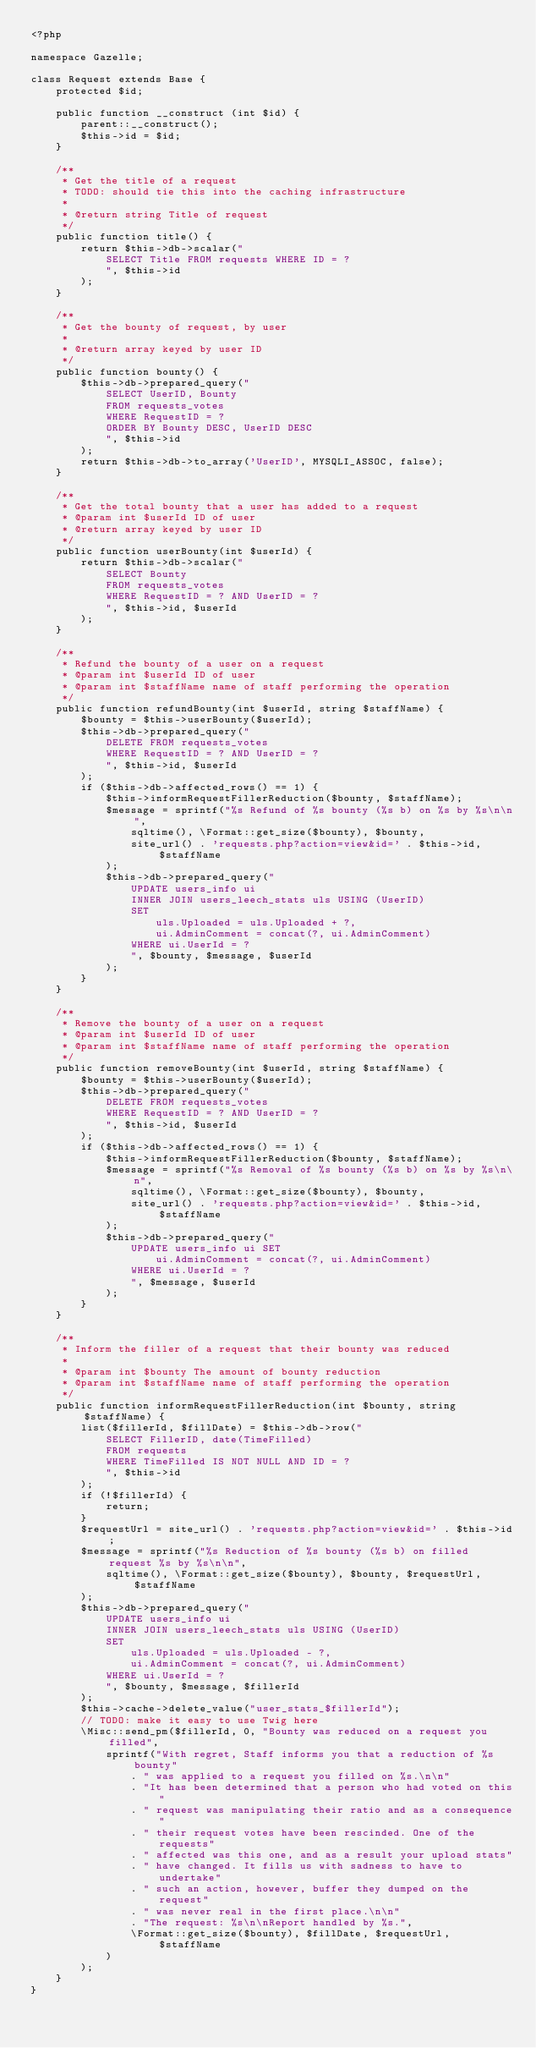<code> <loc_0><loc_0><loc_500><loc_500><_PHP_><?php

namespace Gazelle;

class Request extends Base {
    protected $id;

    public function __construct (int $id) {
        parent::__construct();
        $this->id = $id;
    }

    /**
     * Get the title of a request
     * TODO: should tie this into the caching infrastructure
     *
     * @return string Title of request
     */
    public function title() {
        return $this->db->scalar("
            SELECT Title FROM requests WHERE ID = ?
            ", $this->id
        );
    }

    /**
     * Get the bounty of request, by user
     *
     * @return array keyed by user ID
     */
    public function bounty() {
        $this->db->prepared_query("
            SELECT UserID, Bounty
            FROM requests_votes
            WHERE RequestID = ?
            ORDER BY Bounty DESC, UserID DESC
            ", $this->id
        );
        return $this->db->to_array('UserID', MYSQLI_ASSOC, false);
    }

    /**
     * Get the total bounty that a user has added to a request
     * @param int $userId ID of user
     * @return array keyed by user ID
     */
    public function userBounty(int $userId) {
        return $this->db->scalar("
            SELECT Bounty
            FROM requests_votes
            WHERE RequestID = ? AND UserID = ?
            ", $this->id, $userId
        );
    }

    /**
     * Refund the bounty of a user on a request
     * @param int $userId ID of user
     * @param int $staffName name of staff performing the operation
     */
    public function refundBounty(int $userId, string $staffName) {
        $bounty = $this->userBounty($userId);
        $this->db->prepared_query("
            DELETE FROM requests_votes
            WHERE RequestID = ? AND UserID = ?
            ", $this->id, $userId
        );
        if ($this->db->affected_rows() == 1) {
            $this->informRequestFillerReduction($bounty, $staffName);
            $message = sprintf("%s Refund of %s bounty (%s b) on %s by %s\n\n",
                sqltime(), \Format::get_size($bounty), $bounty,
                site_url() . 'requests.php?action=view&id=' . $this->id, $staffName
            );
            $this->db->prepared_query("
                UPDATE users_info ui
                INNER JOIN users_leech_stats uls USING (UserID)
                SET
                    uls.Uploaded = uls.Uploaded + ?,
                    ui.AdminComment = concat(?, ui.AdminComment)
                WHERE ui.UserId = ?
                ", $bounty, $message, $userId
            );
        }
    }

    /**
     * Remove the bounty of a user on a request
     * @param int $userId ID of user
     * @param int $staffName name of staff performing the operation
     */
    public function removeBounty(int $userId, string $staffName) {
        $bounty = $this->userBounty($userId);
        $this->db->prepared_query("
            DELETE FROM requests_votes
            WHERE RequestID = ? AND UserID = ?
            ", $this->id, $userId
        );
        if ($this->db->affected_rows() == 1) {
            $this->informRequestFillerReduction($bounty, $staffName);
            $message = sprintf("%s Removal of %s bounty (%s b) on %s by %s\n\n",
                sqltime(), \Format::get_size($bounty), $bounty,
                site_url() . 'requests.php?action=view&id=' . $this->id, $staffName
            );
            $this->db->prepared_query("
                UPDATE users_info ui SET
                    ui.AdminComment = concat(?, ui.AdminComment)
                WHERE ui.UserId = ?
                ", $message, $userId
            );
        }
    }

    /**
     * Inform the filler of a request that their bounty was reduced
     *
     * @param int $bounty The amount of bounty reduction
     * @param int $staffName name of staff performing the operation
     */
    public function informRequestFillerReduction(int $bounty, string $staffName) {
        list($fillerId, $fillDate) = $this->db->row("
            SELECT FillerID, date(TimeFilled)
            FROM requests
            WHERE TimeFilled IS NOT NULL AND ID = ?
            ", $this->id
        );
        if (!$fillerId) {
            return;
        }
        $requestUrl = site_url() . 'requests.php?action=view&id=' . $this->id;
        $message = sprintf("%s Reduction of %s bounty (%s b) on filled request %s by %s\n\n",
            sqltime(), \Format::get_size($bounty), $bounty, $requestUrl, $staffName
        );
        $this->db->prepared_query("
            UPDATE users_info ui
            INNER JOIN users_leech_stats uls USING (UserID)
            SET
                uls.Uploaded = uls.Uploaded - ?,
                ui.AdminComment = concat(?, ui.AdminComment)
            WHERE ui.UserId = ?
            ", $bounty, $message, $fillerId
        );
        $this->cache->delete_value("user_stats_$fillerId");
        // TODO: make it easy to use Twig here
        \Misc::send_pm($fillerId, 0, "Bounty was reduced on a request you filled",
            sprintf("With regret, Staff informs you that a reduction of %s bounty"
                . " was applied to a request you filled on %s.\n\n"
                . "It has been determined that a person who had voted on this"
                . " request was manipulating their ratio and as a consequence"
                . " their request votes have been rescinded. One of the requests"
                . " affected was this one, and as a result your upload stats"
                . " have changed. It fills us with sadness to have to undertake"
                . " such an action, however, buffer they dumped on the request"
                . " was never real in the first place.\n\n"
                . "The request: %s\n\nReport handled by %s.",
                \Format::get_size($bounty), $fillDate, $requestUrl, $staffName
            )
        );
    }
}
</code> 